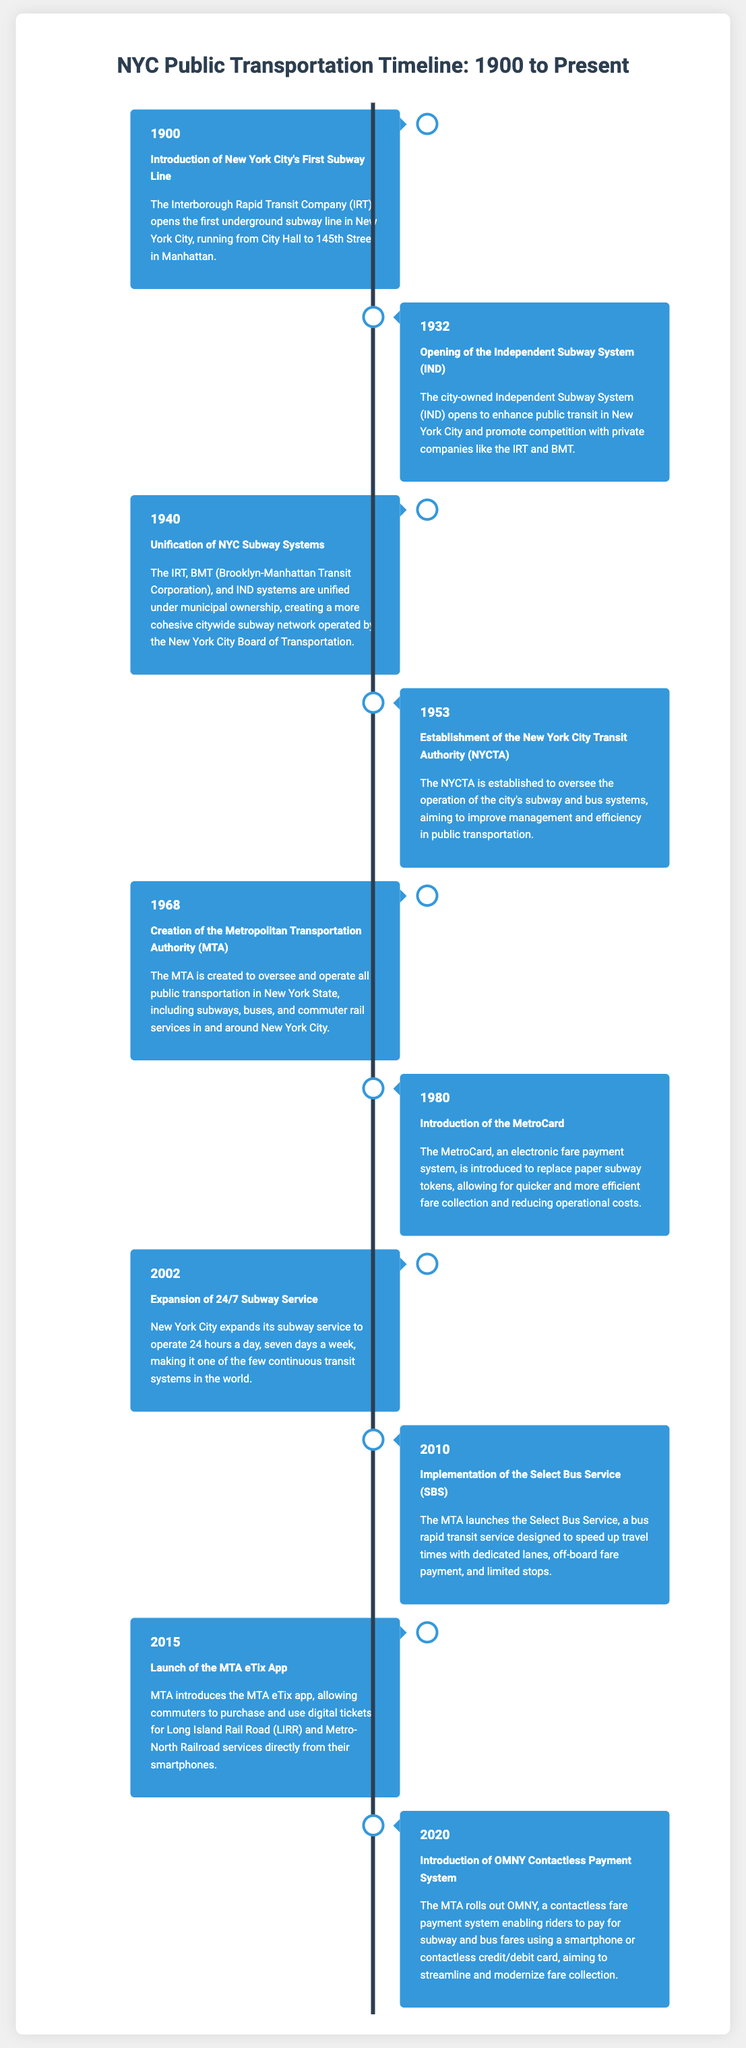what year did the first subway line open in NYC? The document states that the first subway line in New York City opened in 1900.
Answer: 1900 which subway system opened in 1932? According to the timeline, the Independent Subway System (IND) opened in 1932.
Answer: Independent Subway System (IND) what major change occurred in 1940? The document indicates that in 1940, the unification of NYC subway systems took place.
Answer: Unification of NYC Subway Systems what was established in 1953? The timeline notes that the New York City Transit Authority (NYCTA) was established in 1953.
Answer: New York City Transit Authority (NYCTA) what payment system was introduced in 1980? The doc states that the MetroCard payment system was introduced in 1980.
Answer: MetroCard how many subway systems were unified in 1940? The document mentions that three subway systems (IRT, BMT, IND) were unified in 1940.
Answer: Three what was launched in 2010? The document states that the Select Bus Service (SBS) was implemented in 2010.
Answer: Select Bus Service (SBS) what innovative payment method was introduced in 2020? The timeline shows that OMNY, a contactless payment system, was introduced in 2020.
Answer: OMNY which app was launched in 2015? The document states that the MTA eTix app was launched in 2015.
Answer: MTA eTix App 